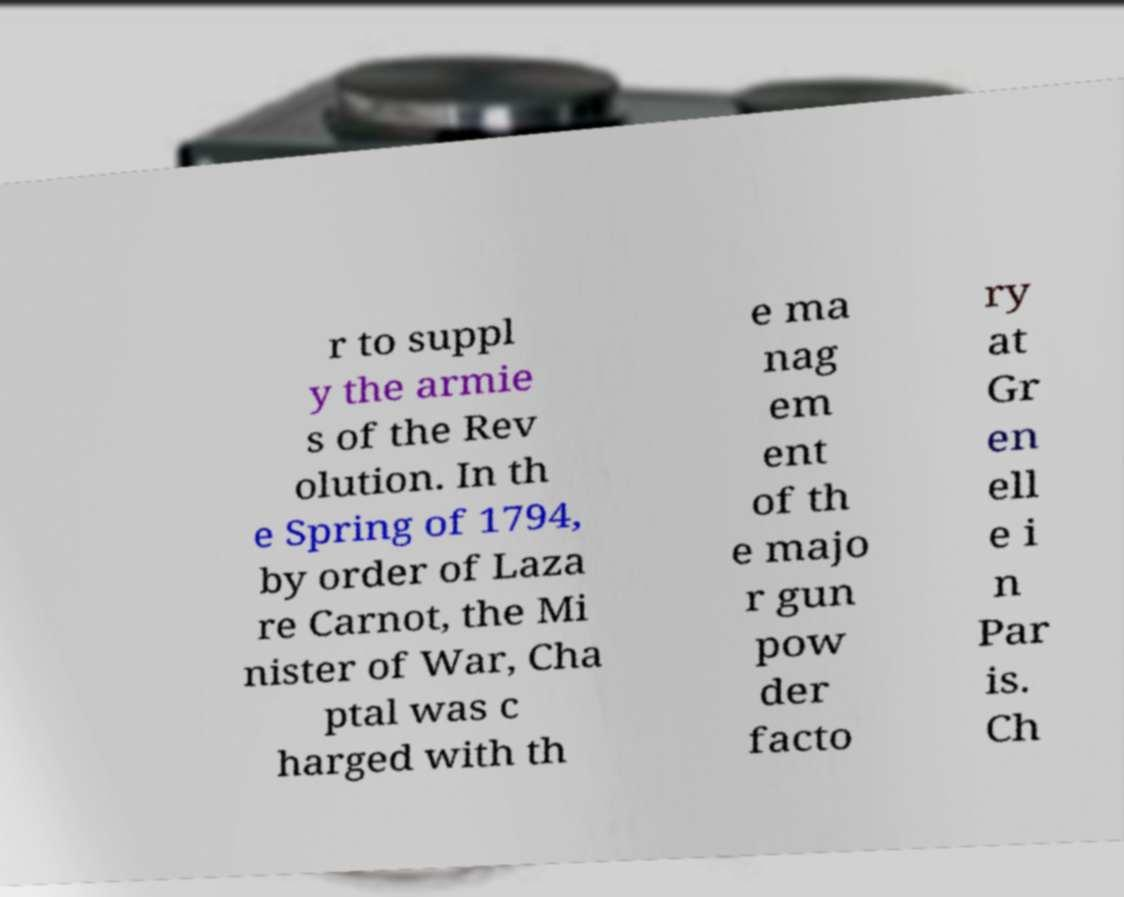Can you read and provide the text displayed in the image?This photo seems to have some interesting text. Can you extract and type it out for me? r to suppl y the armie s of the Rev olution. In th e Spring of 1794, by order of Laza re Carnot, the Mi nister of War, Cha ptal was c harged with th e ma nag em ent of th e majo r gun pow der facto ry at Gr en ell e i n Par is. Ch 